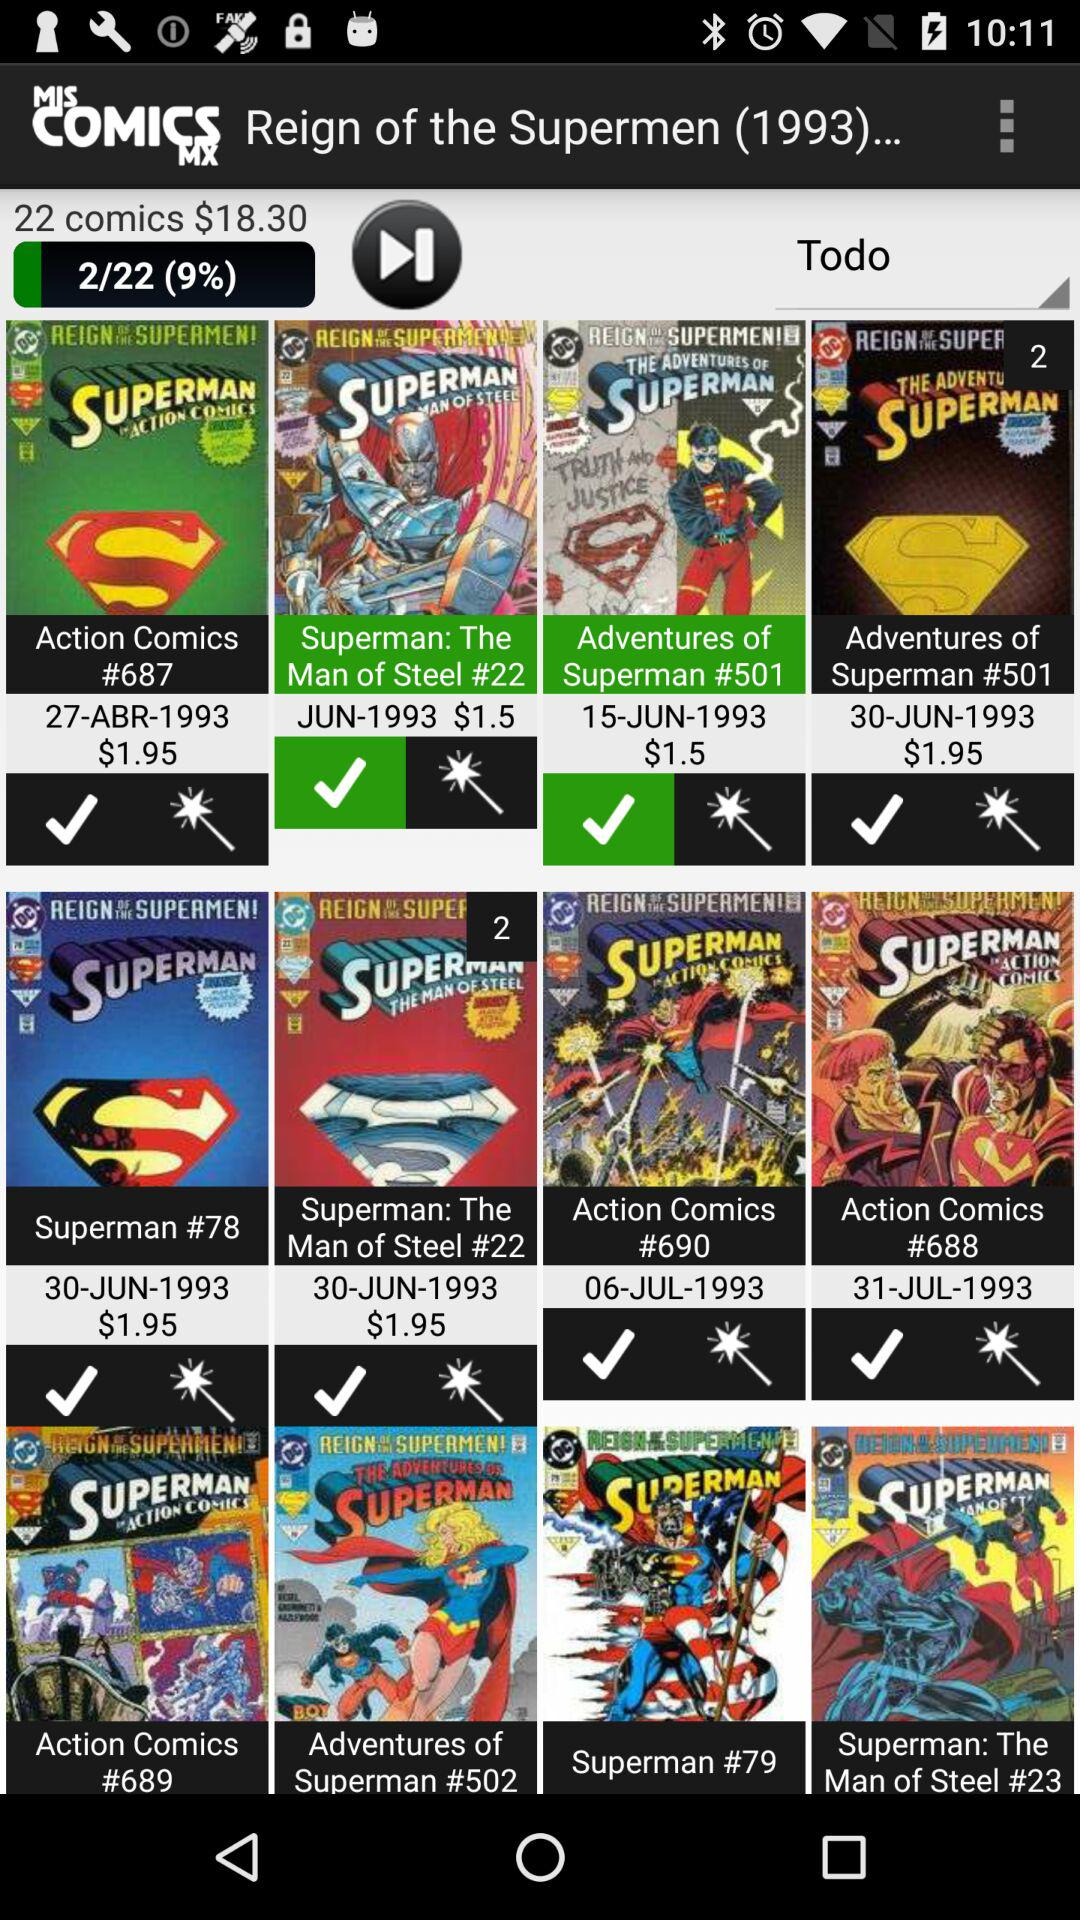What percentage of comics are completed? The percentage of completed comics are 9. 